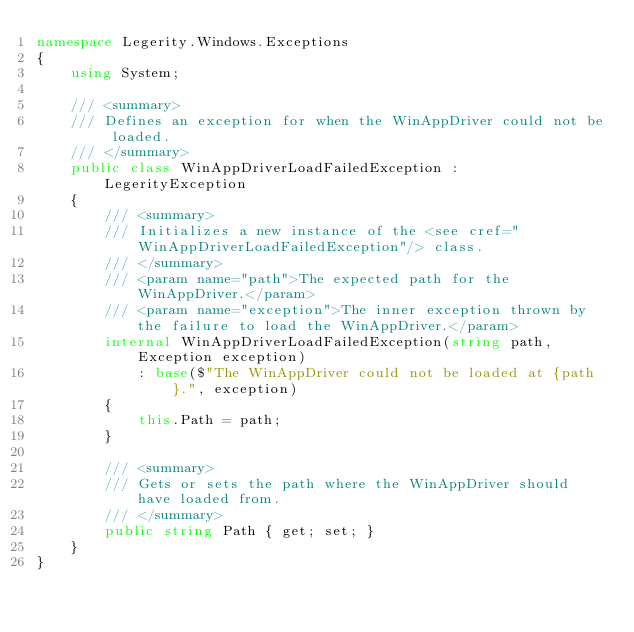<code> <loc_0><loc_0><loc_500><loc_500><_C#_>namespace Legerity.Windows.Exceptions
{
    using System;

    /// <summary>
    /// Defines an exception for when the WinAppDriver could not be loaded.
    /// </summary>
    public class WinAppDriverLoadFailedException : LegerityException
    {
        /// <summary>
        /// Initializes a new instance of the <see cref="WinAppDriverLoadFailedException"/> class.
        /// </summary>
        /// <param name="path">The expected path for the WinAppDriver.</param>
        /// <param name="exception">The inner exception thrown by the failure to load the WinAppDriver.</param>
        internal WinAppDriverLoadFailedException(string path, Exception exception)
            : base($"The WinAppDriver could not be loaded at {path}.", exception)
        {
            this.Path = path;
        }

        /// <summary>
        /// Gets or sets the path where the WinAppDriver should have loaded from.
        /// </summary>
        public string Path { get; set; }
    }
}</code> 